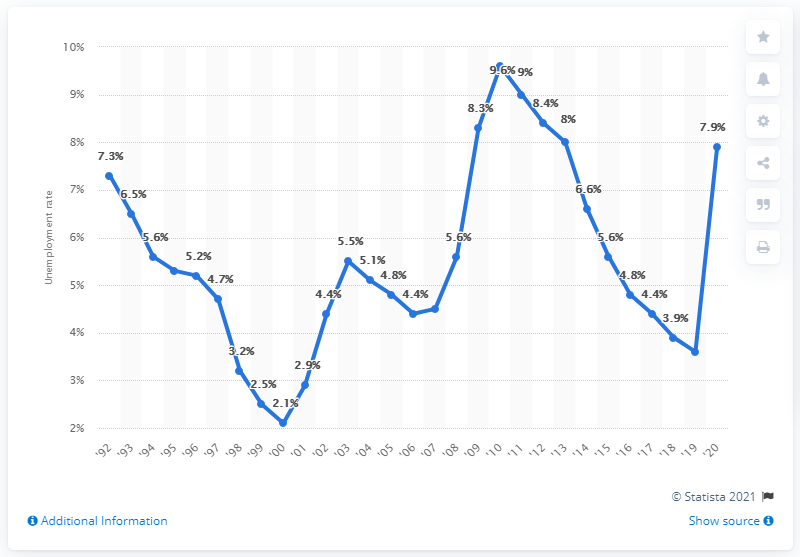Outline some significant characteristics in this image. In 2010, Connecticut's highest unemployment rate was 9.6%. In 2020, the unemployment rate in Connecticut was 7.9%. 